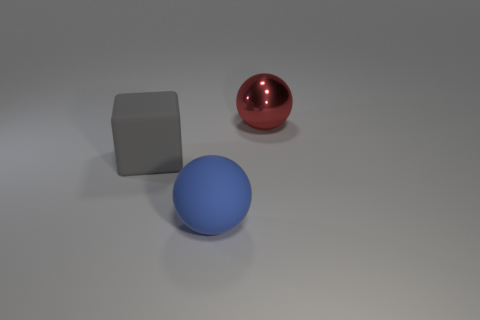Add 3 red objects. How many objects exist? 6 Subtract all cubes. How many objects are left? 2 Subtract 1 blocks. How many blocks are left? 0 Add 2 big cubes. How many big cubes exist? 3 Subtract 0 red cylinders. How many objects are left? 3 Subtract all gray spheres. Subtract all purple cylinders. How many spheres are left? 2 Subtract all gray objects. Subtract all rubber cubes. How many objects are left? 1 Add 1 large spheres. How many large spheres are left? 3 